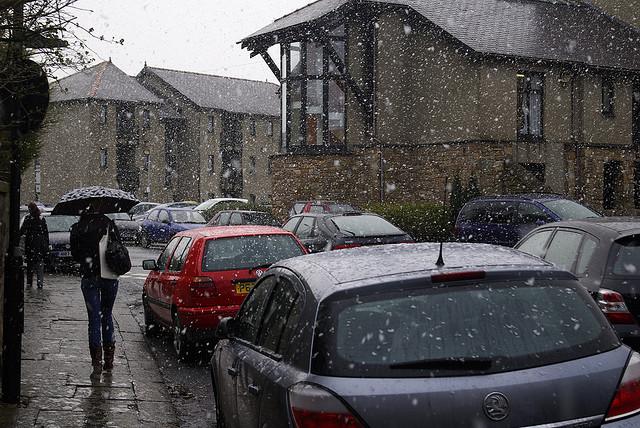How many cars are parked near each other?
Give a very brief answer. 2. What is falling from the sky?
Give a very brief answer. Snow. Why are the trees bare?
Be succinct. Winter. What color umbrella is the person on the left carrying?
Give a very brief answer. Black. What type of vehicle are the people driving?
Give a very brief answer. Cars. Why would someone want an umbrella?
Answer briefly. It's raining. 